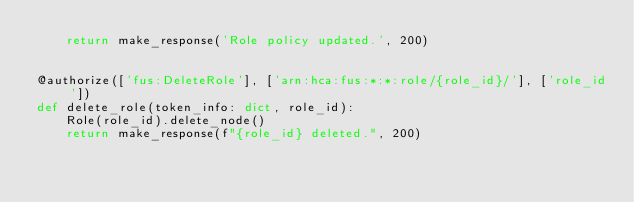Convert code to text. <code><loc_0><loc_0><loc_500><loc_500><_Python_>    return make_response('Role policy updated.', 200)


@authorize(['fus:DeleteRole'], ['arn:hca:fus:*:*:role/{role_id}/'], ['role_id'])
def delete_role(token_info: dict, role_id):
    Role(role_id).delete_node()
    return make_response(f"{role_id} deleted.", 200)
</code> 